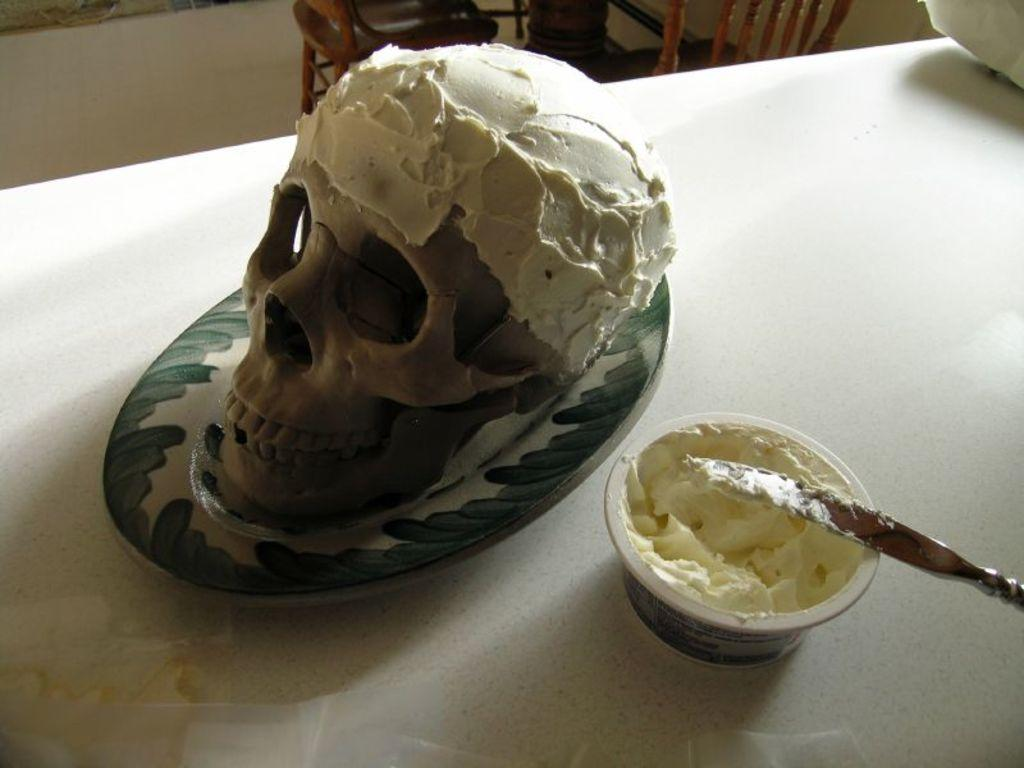What is placed on the plate in the image? There is a skull on a plate in the image. What is on the table in the image? There is a bowl on a table in the image. What color is the table in the image? The table is white in color. How many times can you hear the skull talking in the image? The image does not depict any sound or conversation, so it is not possible to determine how many times the skull is talking. 